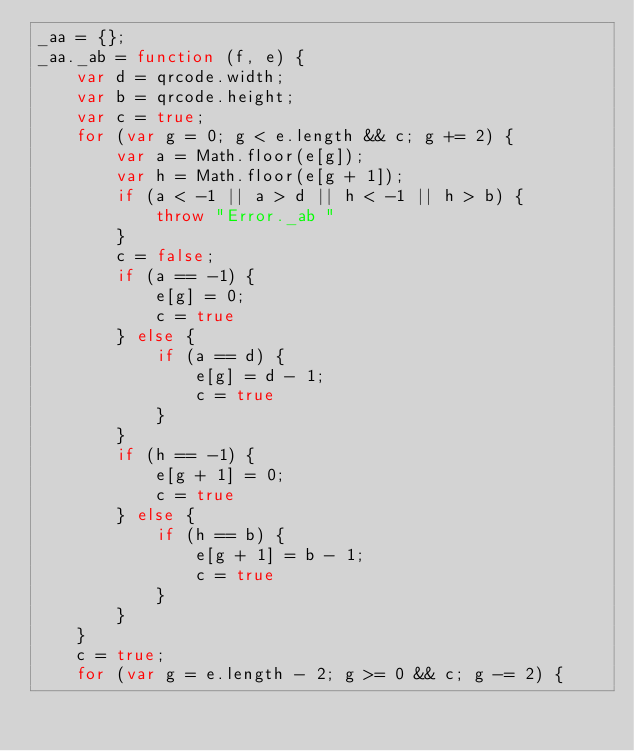Convert code to text. <code><loc_0><loc_0><loc_500><loc_500><_JavaScript_>_aa = {};
_aa._ab = function (f, e) {
    var d = qrcode.width;
    var b = qrcode.height;
    var c = true;
    for (var g = 0; g < e.length && c; g += 2) {
        var a = Math.floor(e[g]);
        var h = Math.floor(e[g + 1]);
        if (a < -1 || a > d || h < -1 || h > b) {
            throw "Error._ab "
        }
        c = false;
        if (a == -1) {
            e[g] = 0;
            c = true
        } else {
            if (a == d) {
                e[g] = d - 1;
                c = true
            }
        }
        if (h == -1) {
            e[g + 1] = 0;
            c = true
        } else {
            if (h == b) {
                e[g + 1] = b - 1;
                c = true
            }
        }
    }
    c = true;
    for (var g = e.length - 2; g >= 0 && c; g -= 2) {</code> 